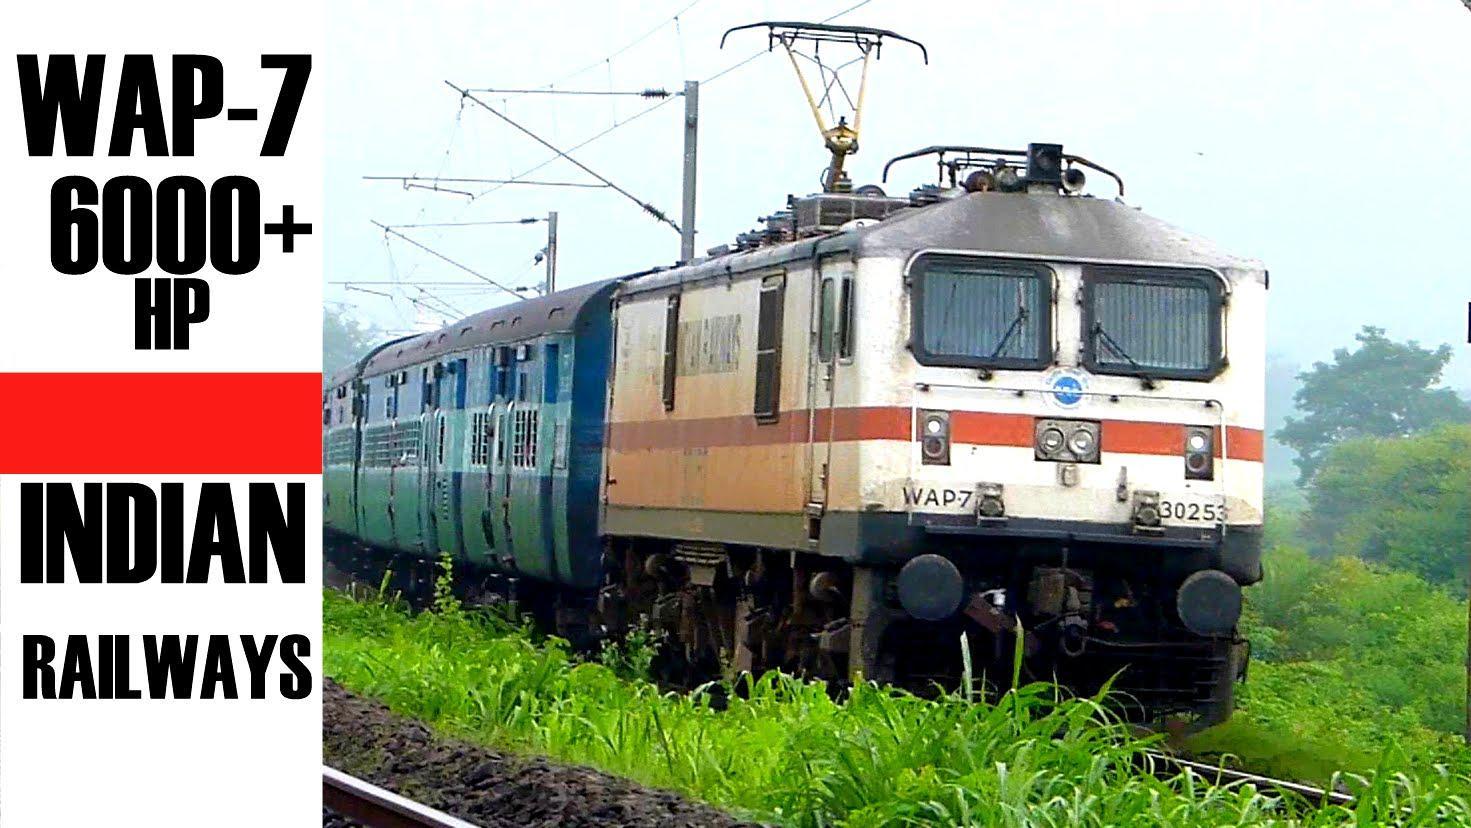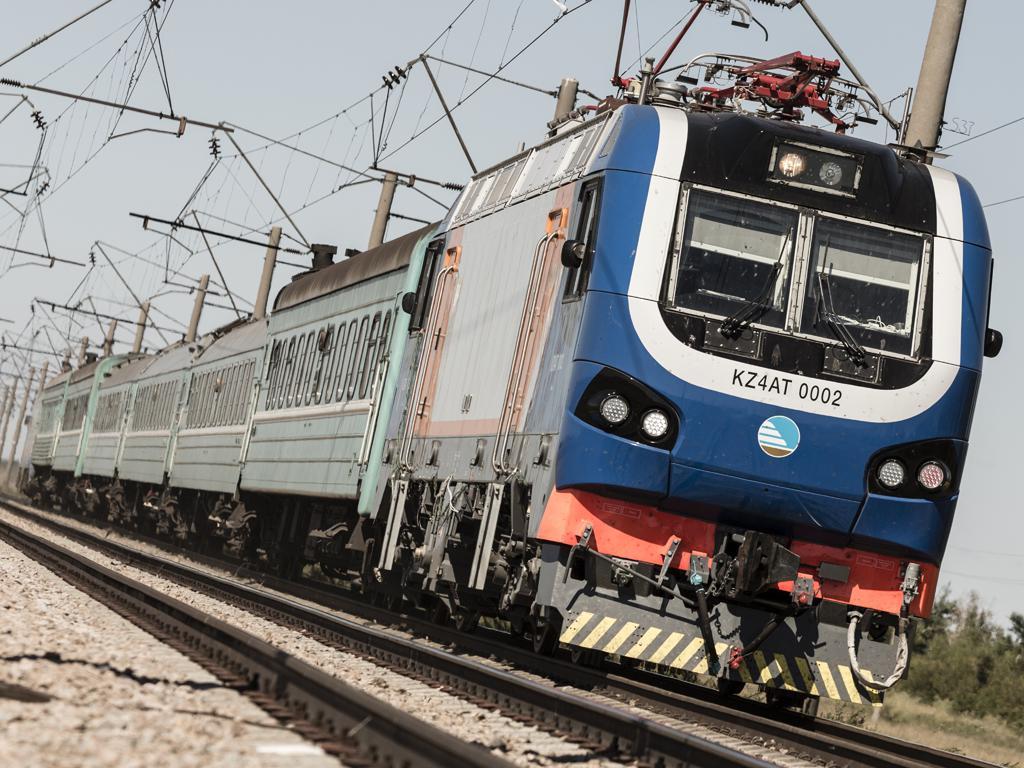The first image is the image on the left, the second image is the image on the right. For the images shown, is this caption "The front car of a train is red-orange, and the train is shown at an angle heading down a straight track." true? Answer yes or no. No. The first image is the image on the left, the second image is the image on the right. Analyze the images presented: Is the assertion "Exactly two locomotives are different colors and have different window designs, but are both headed in the same general direction and pulling a line of train cars." valid? Answer yes or no. Yes. 